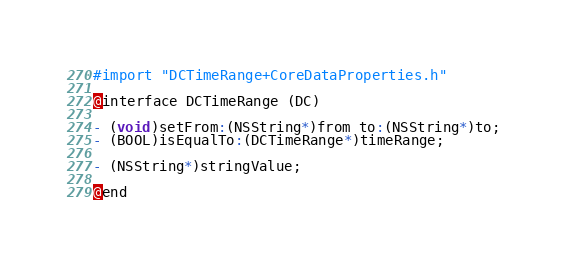Convert code to text. <code><loc_0><loc_0><loc_500><loc_500><_C_>
#import "DCTimeRange+CoreDataProperties.h"

@interface DCTimeRange (DC)

- (void)setFrom:(NSString*)from to:(NSString*)to;
- (BOOL)isEqualTo:(DCTimeRange*)timeRange;

- (NSString*)stringValue;

@end
</code> 